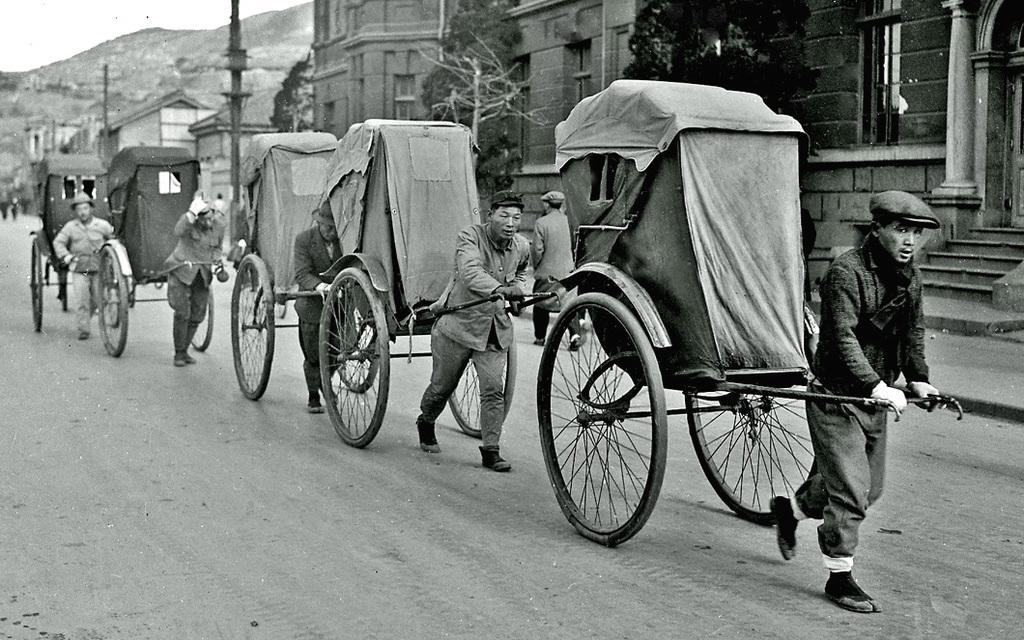What activity are the people in the image engaged in? The people in the image are pulling rickshaws. What type of natural elements can be seen in the image? There are trees visible in the image. What type of man-made structures are present in the image? There are buildings in the image. What type of pathway is visible in the image? There is a road in the image. Can you see any goldfish swimming in the alley in the image? There is no alley or goldfish present in the image. 